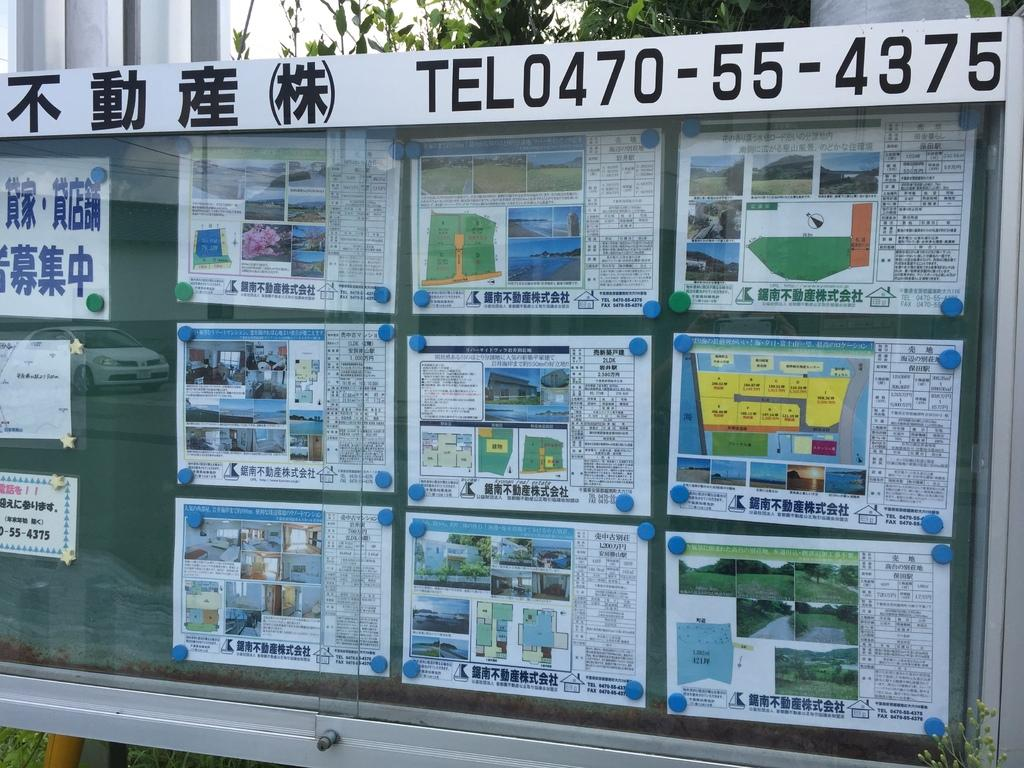<image>
Render a clear and concise summary of the photo. An outdoor display showing homes for sale with a number to call of TEL0470-55-4375 